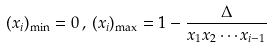Convert formula to latex. <formula><loc_0><loc_0><loc_500><loc_500>( x _ { i } ) _ { \min } = 0 \, , \, ( x _ { i } ) _ { \max } = 1 - \frac { \Delta } { x _ { 1 } x _ { 2 } \cdots x _ { i - 1 } }</formula> 